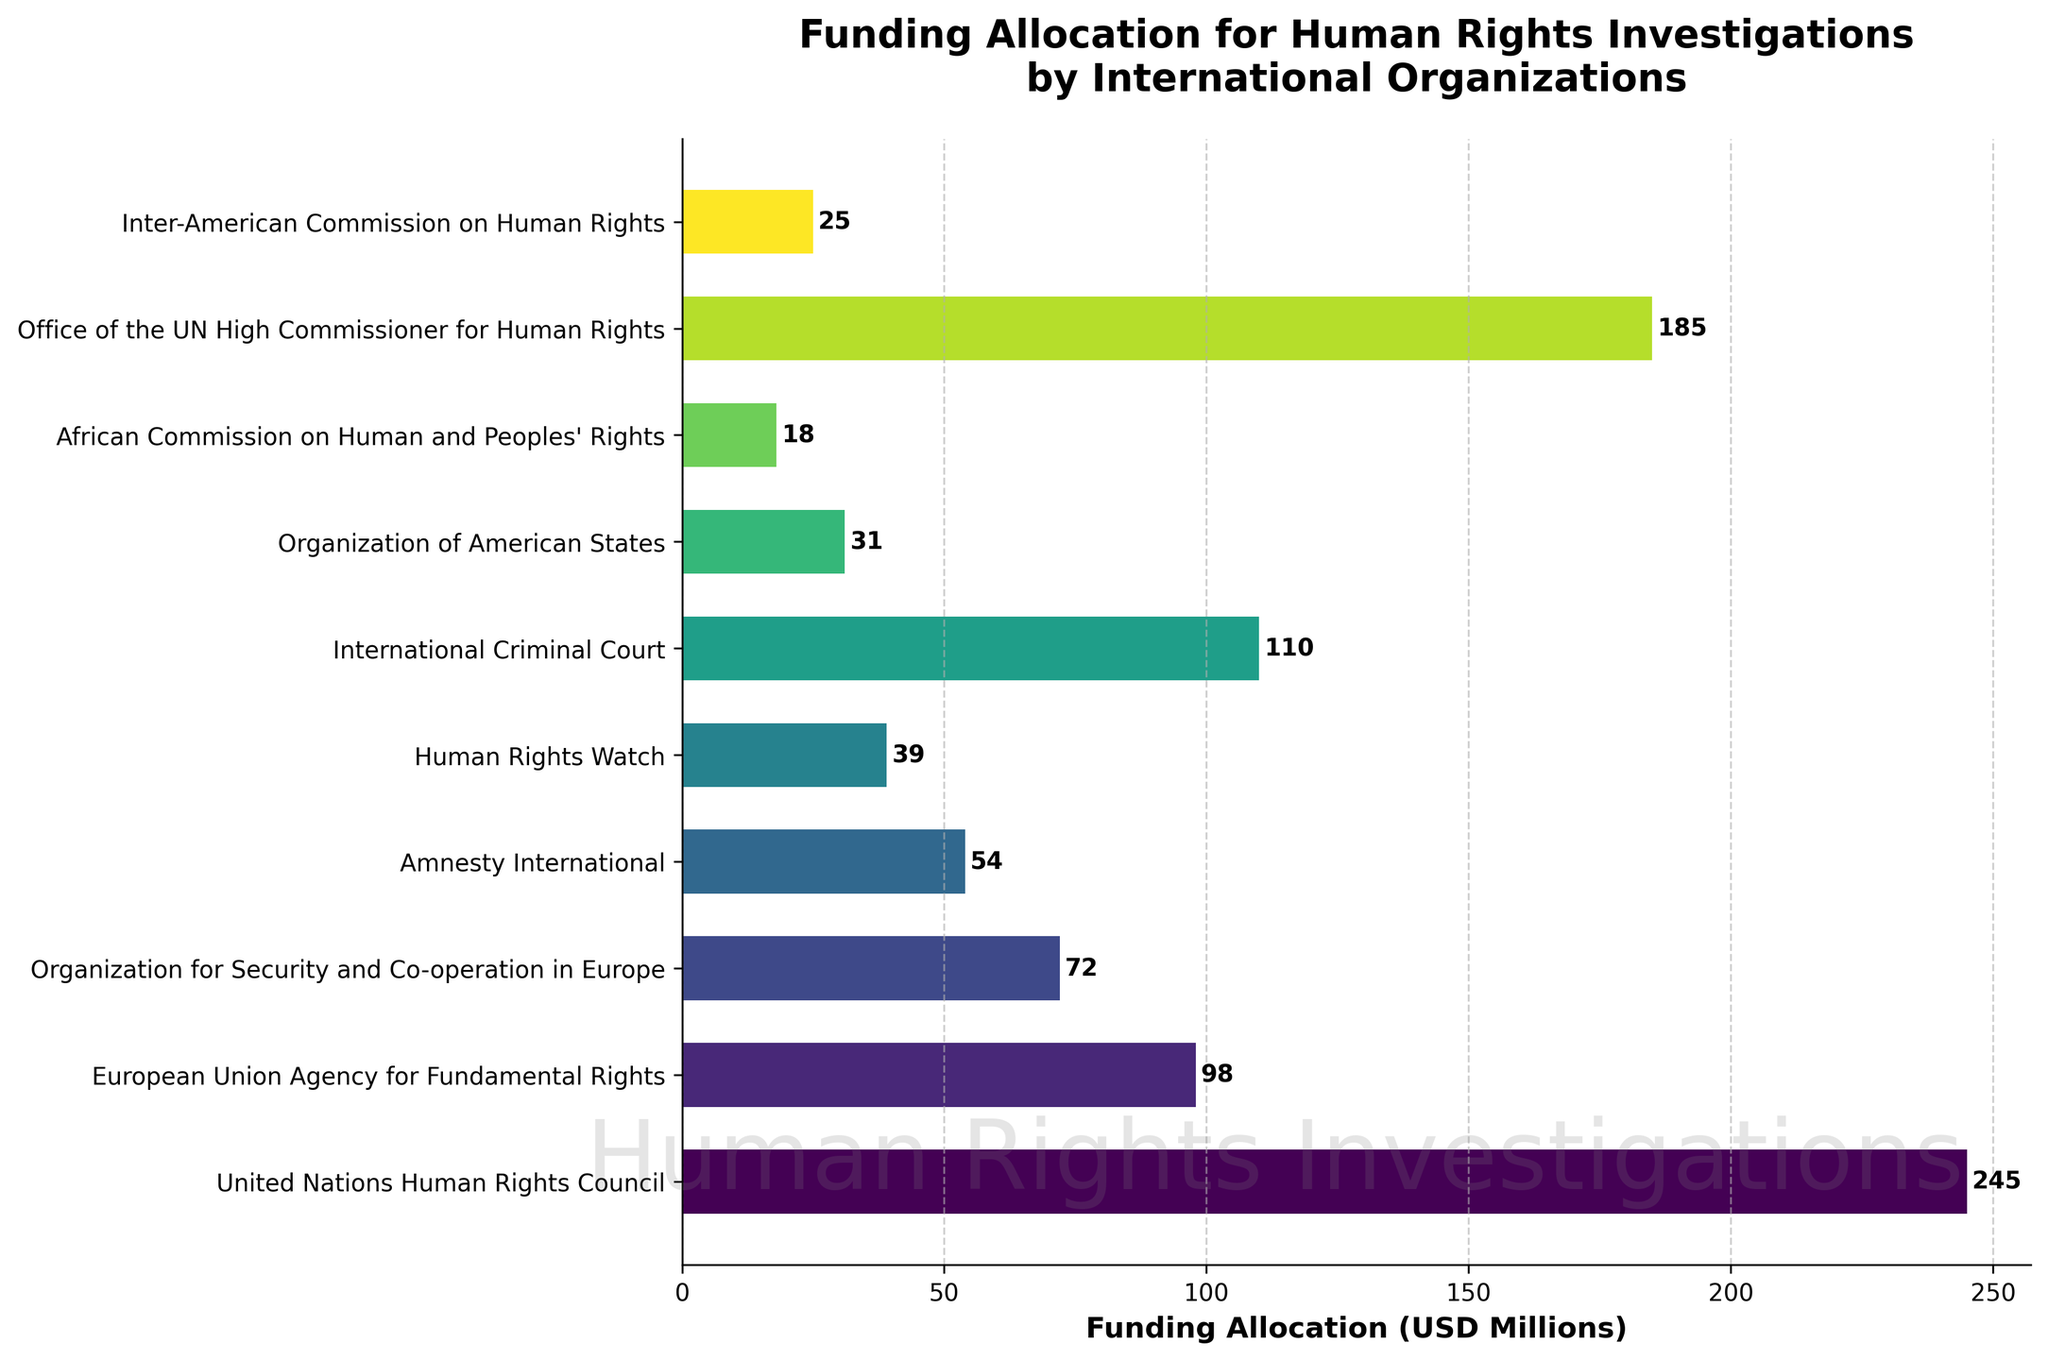What is the total funding allocation for the top three organizations? To find the total funding allocation for the top three organizations, identify the organizations with the highest funding and sum their allocations. The top three organizations are United Nations Human Rights Council (245 USD Millions), Office of the UN High Commissioner for Human Rights (185 USD Millions), and International Criminal Court (110 USD Millions). Summing these, 245 + 185 + 110 = 540 USD Millions.
Answer: 540 USD Millions Which organization has the lowest funding allocation? By examining the bar lengths and the labels, it is clear that the African Commission on Human and Peoples' Rights has the shortest bar and thus the lowest funding allocation at 18 USD Millions.
Answer: African Commission on Human and Peoples' Rights How much more funding does the United Nations Human Rights Council receive compared to Amnesty International? Compare the funding values for these two organizations. The United Nations Human Rights Council receives 245 USD Millions, and Amnesty International receives 54 USD Millions. Calculate the difference: 245 - 54 = 191 USD Millions.
Answer: 191 USD Millions Which organizations have a funding allocation greater than 100 USD Millions? Identify all organizations with bars extending beyond the 100 USD Millions mark. The organizations are United Nations Human Rights Council (245 USD Millions), Office of the UN High Commissioner for Human Rights (185 USD Millions), and International Criminal Court (110 USD Millions).
Answer: United Nations Human Rights Council, Office of the UN High Commissioner for Human Rights, International Criminal Court What is the difference in funding allocation between the highest and lowest funded organizations? The highest funded organization is the United Nations Human Rights Council with 245 USD Millions, and the lowest funded is the African Commission on Human and Peoples' Rights with 18 USD Millions. Calculate the difference: 245 - 18 = 227 USD Millions.
Answer: 227 USD Millions How much total funding is allocated by the bottom five organizations by funding amount? Identify the bottom five organizations by funding amount and sum their allocations. The bottom five are African Commission on Human and Peoples' Rights (18 USD Millions), Organization of American States (31 USD Millions), Inter-American Commission on Human Rights (25 USD Millions), Human Rights Watch (39 USD Millions), and Amnesty International (54 USD Millions). Summing these: 18 + 31 + 25 + 39 + 54 = 167 USD Millions.
Answer: 167 USD Millions What is the average funding allocation across all organizations? Calculate the total funding allocation by summing all values: 245 + 98 + 72 + 54 + 39 + 110 + 31 + 18 + 185 + 25 = 877 USD Millions. There are 10 organizations, so divide the total by 10: 877 / 10 = 87.7 USD Millions.
Answer: 87.7 USD Millions Between the European Union Agency for Fundamental Rights and Human Rights Watch, which has more funding and by how much? Compare the funding values of these two organizations. European Union Agency for Fundamental Rights has 98 USD Millions, and Human Rights Watch has 39 USD Millions. Calculate the difference: 98 - 39 = 59 USD Millions.
Answer: European Union Agency for Fundamental Rights by 59 USD Millions Which organization is third in terms of funding allocation? By visual inspection, the third longest bar corresponds to the International Criminal Court with a funding allocation of 110 USD Millions.
Answer: International Criminal Court 